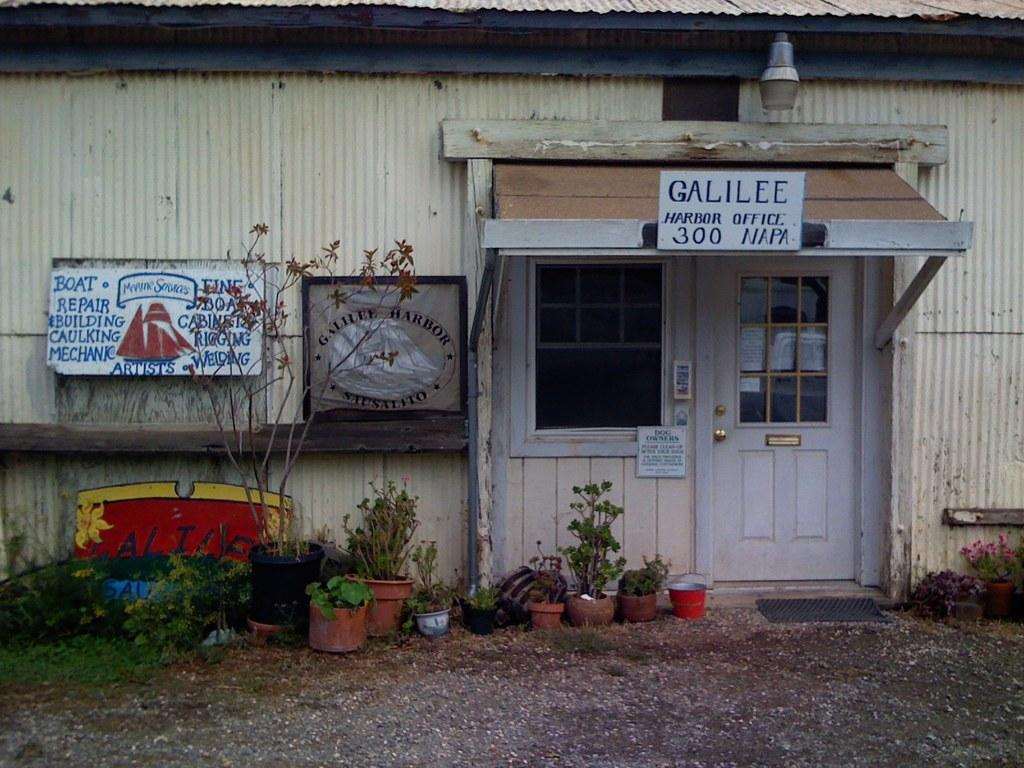What type of structure is present in the image? There is a house in the image. What part of the house is visible in the image? There is a door in the image. What can be seen on the boards in the image? The boards in the image have text on them. What type of vegetation is present in the image? There are plants in the image. What is visible at the bottom of the image? There is ground visible at the bottom of the image. Can you tell me how many zebras are grazing on the grass in the image? There are no zebras present in the image; it features a house, a door, boards with text, plants, and ground. What color is the goldfish swimming in the pond in the image? There is no pond or goldfish present in the image. 